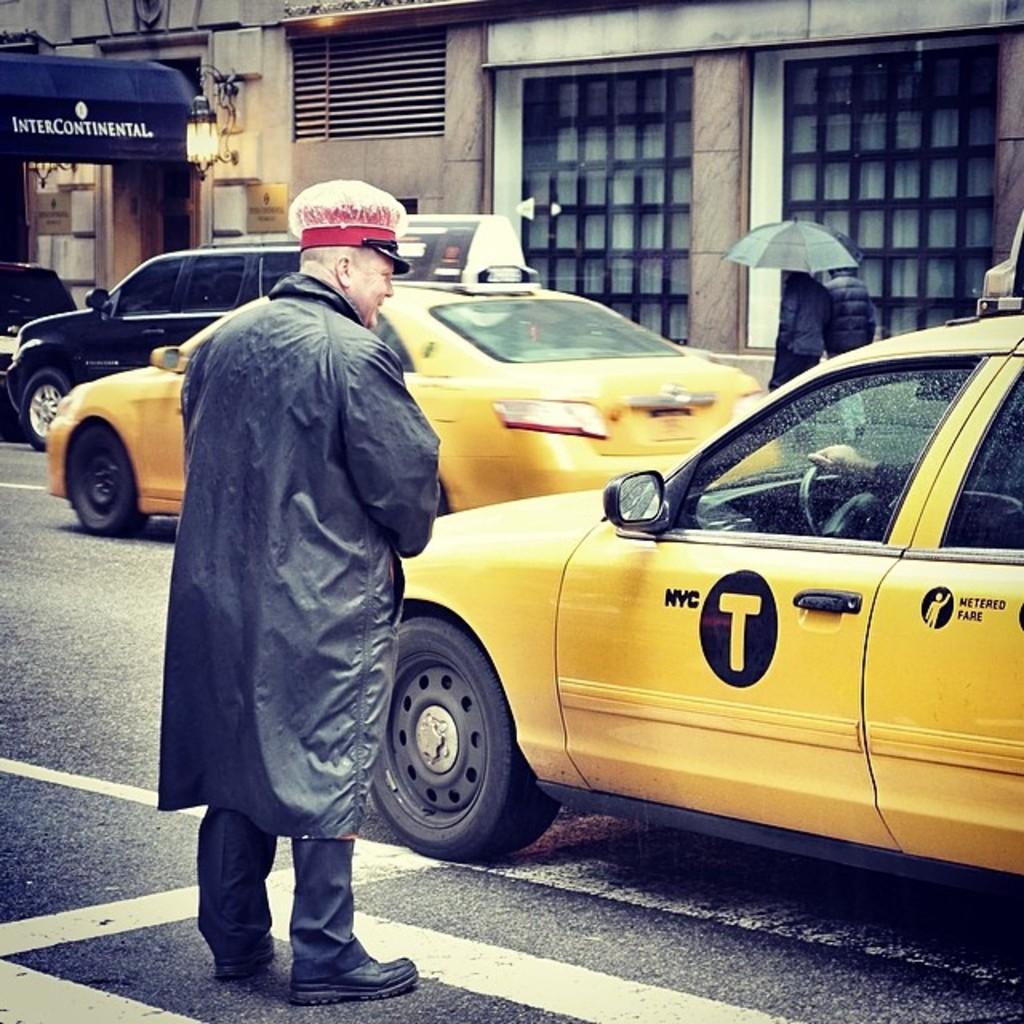What are the initials of the city this cab is in?
Offer a very short reply. Nyc. What is on the blue awning?
Your answer should be compact. Intercontinental. 